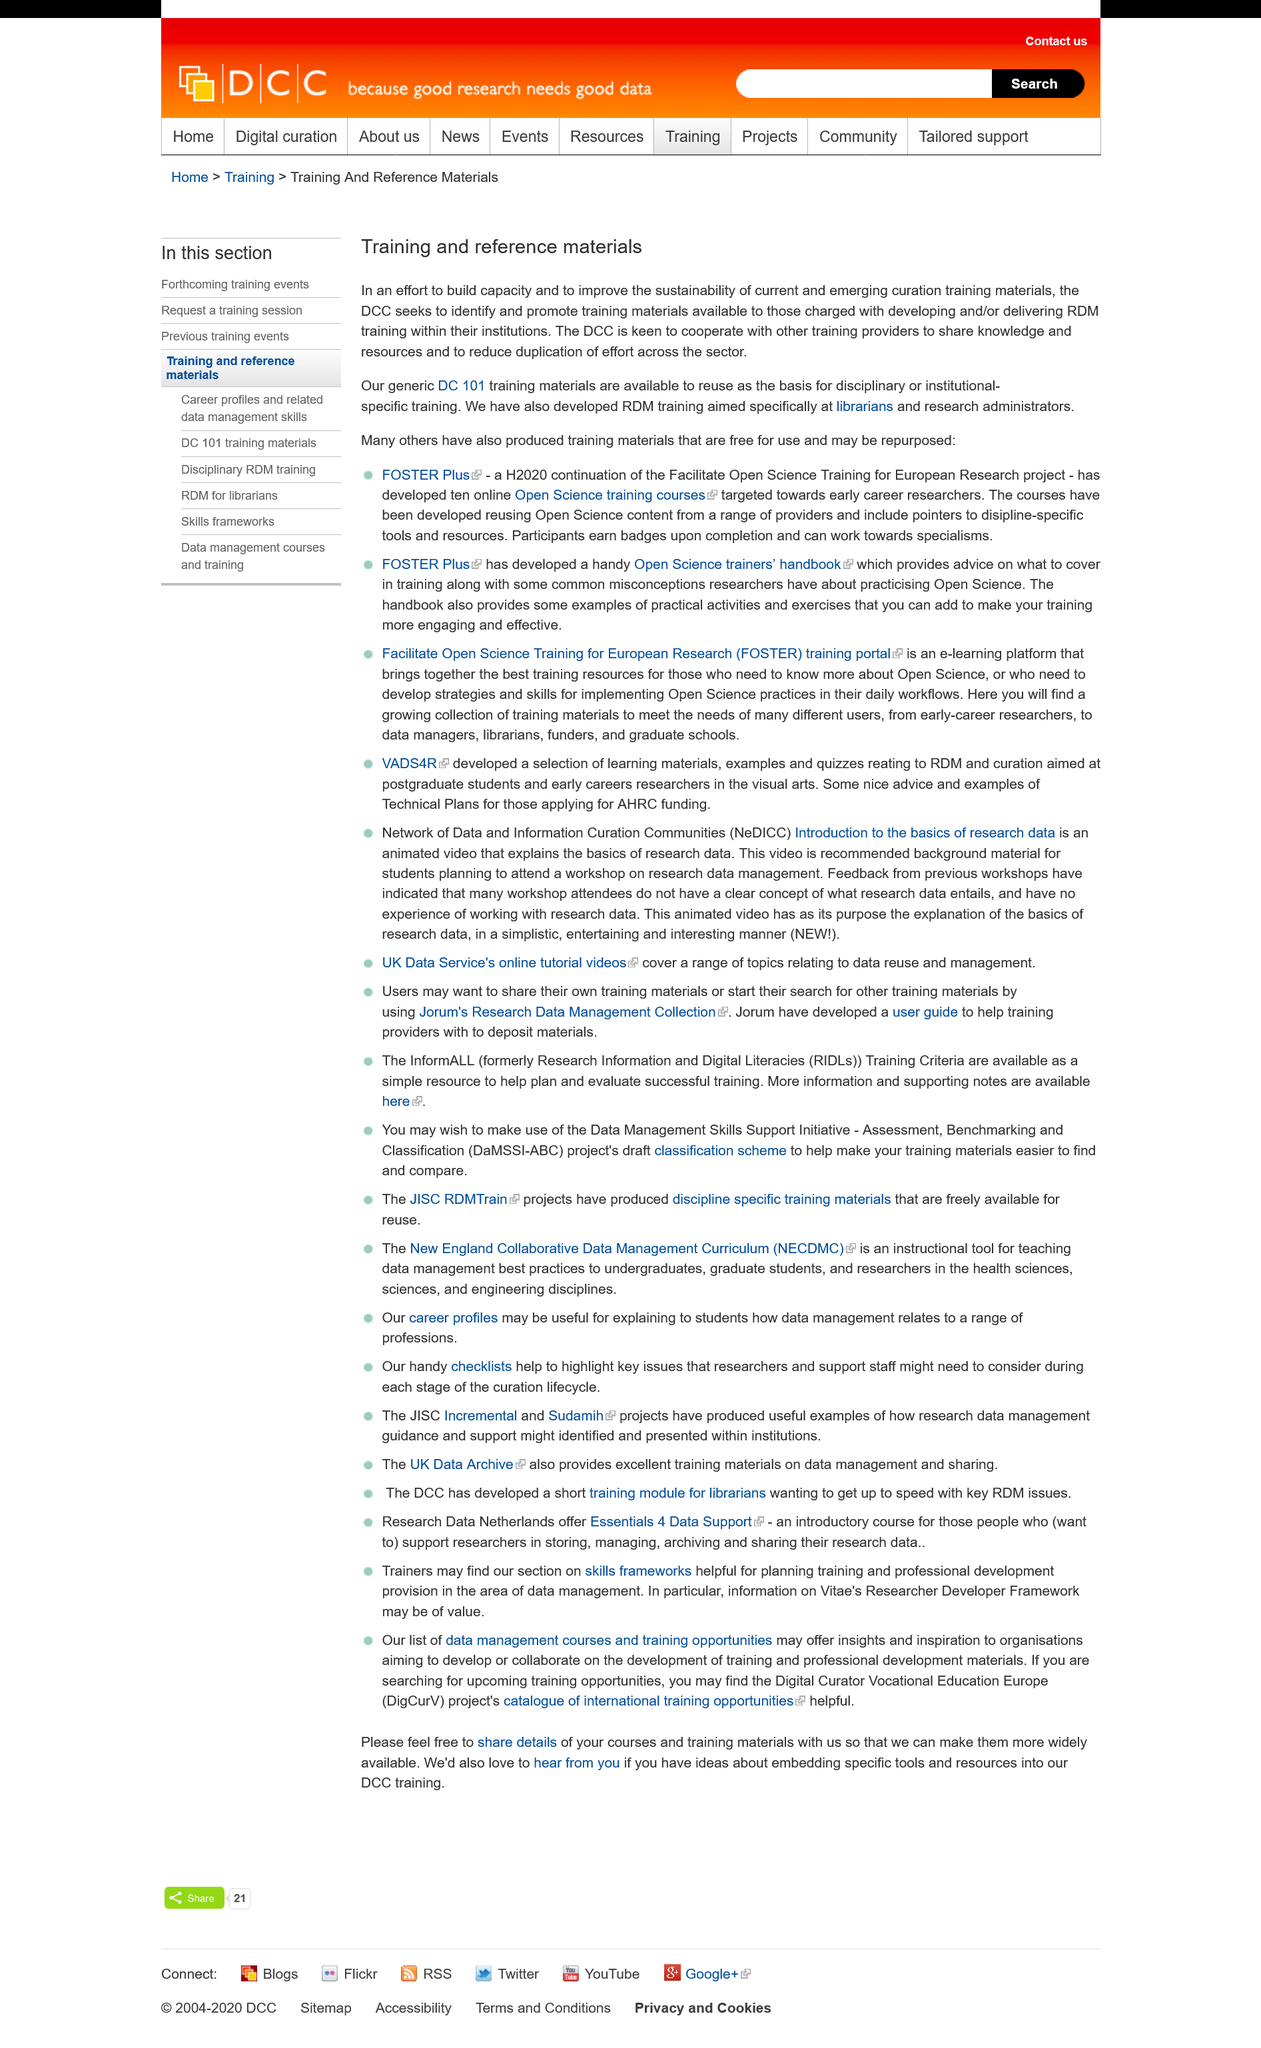Point out several critical features in this image. The DCC desires to collaborate with other training providers in order to share knowledge and resources, as well as to avoid unnecessary duplication of efforts within the sector. The Digital Curation Centre is attempting to identify and promote training materials as part of a mission to enhance the capacity and sustainability of current and future curation training materials. RDM training has been specifically developed for librarians and research administrators, and it has been demonstrated that this training has improved their skills in managing research data. 